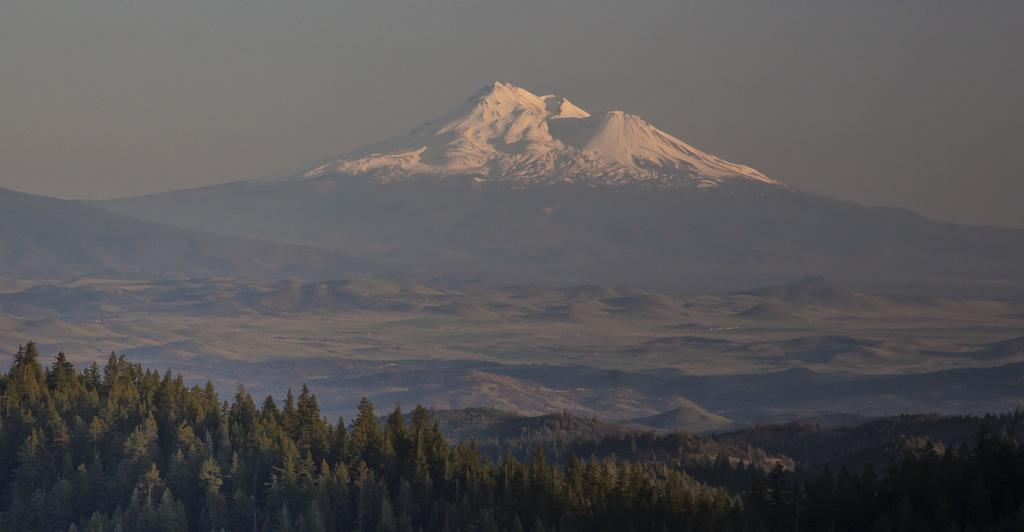What is located in the foreground of the image? There is a group of trees in the foreground of the image. What can be seen in the background of the image? There are mountains and the sky visible in the background of the image. What type of blade is being used by the laborer in the image? There is no laborer or blade present in the image. How does the twist in the image affect the landscape? There is no twist present in the image; it is a natural landscape featuring trees, mountains, and the sky. 